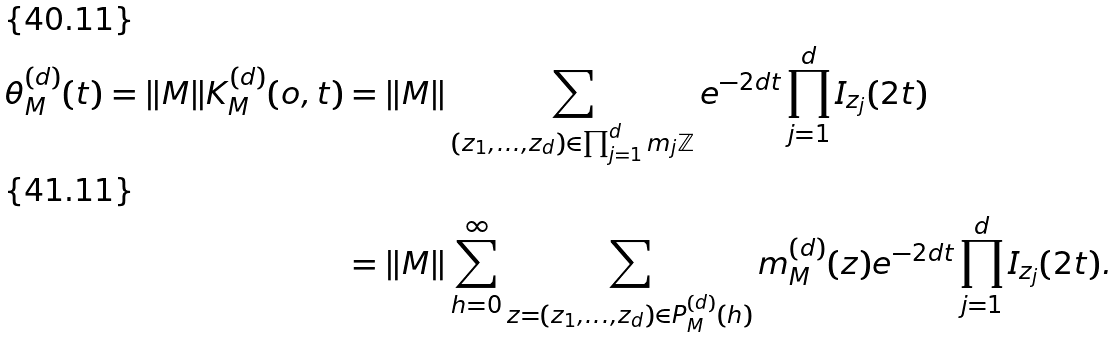Convert formula to latex. <formula><loc_0><loc_0><loc_500><loc_500>\theta ^ { ( d ) } _ { M } ( t ) = \| M \| K ^ { ( d ) } _ { M } ( o , t ) & = \| M \| \sum _ { ( z _ { 1 } , \dots , z _ { d } ) \in \prod ^ { d } _ { j = 1 } m _ { j } \mathbb { Z } } e ^ { - 2 d t } \prod ^ { d } _ { j = 1 } I _ { z _ { j } } ( 2 t ) \\ & = \| M \| \sum ^ { \infty } _ { h = 0 } \sum _ { z = ( z _ { 1 } , \dots , z _ { d } ) \in P ^ { ( d ) } _ { M } ( h ) } m ^ { ( d ) } _ { M } ( z ) e ^ { - 2 d t } \prod ^ { d } _ { j = 1 } I _ { z _ { j } } ( 2 t ) .</formula> 